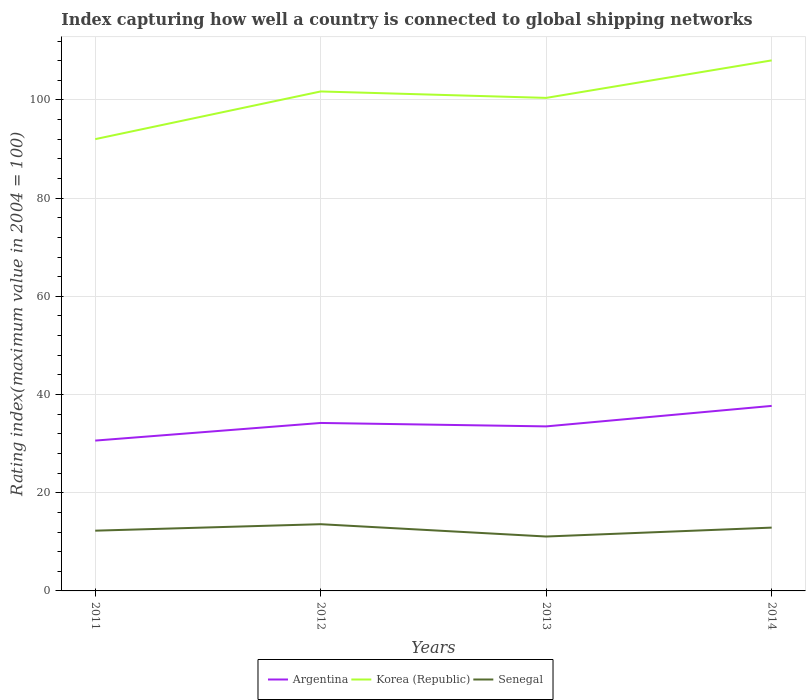How many different coloured lines are there?
Offer a very short reply. 3. Does the line corresponding to Argentina intersect with the line corresponding to Senegal?
Ensure brevity in your answer.  No. Across all years, what is the maximum rating index in Korea (Republic)?
Keep it short and to the point. 92.02. In which year was the rating index in Argentina maximum?
Your answer should be compact. 2011. What is the total rating index in Argentina in the graph?
Offer a terse response. -7.07. What is the difference between the highest and the second highest rating index in Senegal?
Keep it short and to the point. 2.51. How many lines are there?
Offer a terse response. 3. How many years are there in the graph?
Give a very brief answer. 4. What is the difference between two consecutive major ticks on the Y-axis?
Your answer should be very brief. 20. Does the graph contain any zero values?
Give a very brief answer. No. Does the graph contain grids?
Ensure brevity in your answer.  Yes. Where does the legend appear in the graph?
Provide a succinct answer. Bottom center. How many legend labels are there?
Make the answer very short. 3. What is the title of the graph?
Offer a very short reply. Index capturing how well a country is connected to global shipping networks. Does "Vietnam" appear as one of the legend labels in the graph?
Make the answer very short. No. What is the label or title of the X-axis?
Offer a very short reply. Years. What is the label or title of the Y-axis?
Offer a very short reply. Rating index(maximum value in 2004 = 100). What is the Rating index(maximum value in 2004 = 100) of Argentina in 2011?
Provide a short and direct response. 30.62. What is the Rating index(maximum value in 2004 = 100) of Korea (Republic) in 2011?
Offer a very short reply. 92.02. What is the Rating index(maximum value in 2004 = 100) in Senegal in 2011?
Provide a succinct answer. 12.27. What is the Rating index(maximum value in 2004 = 100) of Argentina in 2012?
Offer a very short reply. 34.21. What is the Rating index(maximum value in 2004 = 100) of Korea (Republic) in 2012?
Offer a terse response. 101.73. What is the Rating index(maximum value in 2004 = 100) in Senegal in 2012?
Provide a succinct answer. 13.59. What is the Rating index(maximum value in 2004 = 100) of Argentina in 2013?
Offer a terse response. 33.51. What is the Rating index(maximum value in 2004 = 100) in Korea (Republic) in 2013?
Your answer should be compact. 100.42. What is the Rating index(maximum value in 2004 = 100) in Senegal in 2013?
Ensure brevity in your answer.  11.08. What is the Rating index(maximum value in 2004 = 100) of Argentina in 2014?
Make the answer very short. 37.69. What is the Rating index(maximum value in 2004 = 100) of Korea (Republic) in 2014?
Keep it short and to the point. 108.06. What is the Rating index(maximum value in 2004 = 100) in Senegal in 2014?
Make the answer very short. 12.9. Across all years, what is the maximum Rating index(maximum value in 2004 = 100) of Argentina?
Your response must be concise. 37.69. Across all years, what is the maximum Rating index(maximum value in 2004 = 100) of Korea (Republic)?
Your answer should be compact. 108.06. Across all years, what is the maximum Rating index(maximum value in 2004 = 100) in Senegal?
Make the answer very short. 13.59. Across all years, what is the minimum Rating index(maximum value in 2004 = 100) of Argentina?
Give a very brief answer. 30.62. Across all years, what is the minimum Rating index(maximum value in 2004 = 100) in Korea (Republic)?
Your answer should be very brief. 92.02. Across all years, what is the minimum Rating index(maximum value in 2004 = 100) in Senegal?
Offer a terse response. 11.08. What is the total Rating index(maximum value in 2004 = 100) of Argentina in the graph?
Offer a terse response. 136.03. What is the total Rating index(maximum value in 2004 = 100) in Korea (Republic) in the graph?
Provide a succinct answer. 402.23. What is the total Rating index(maximum value in 2004 = 100) of Senegal in the graph?
Your answer should be very brief. 49.84. What is the difference between the Rating index(maximum value in 2004 = 100) in Argentina in 2011 and that in 2012?
Provide a succinct answer. -3.59. What is the difference between the Rating index(maximum value in 2004 = 100) of Korea (Republic) in 2011 and that in 2012?
Your answer should be very brief. -9.71. What is the difference between the Rating index(maximum value in 2004 = 100) of Senegal in 2011 and that in 2012?
Your answer should be compact. -1.32. What is the difference between the Rating index(maximum value in 2004 = 100) of Argentina in 2011 and that in 2013?
Provide a short and direct response. -2.89. What is the difference between the Rating index(maximum value in 2004 = 100) in Korea (Republic) in 2011 and that in 2013?
Keep it short and to the point. -8.4. What is the difference between the Rating index(maximum value in 2004 = 100) of Senegal in 2011 and that in 2013?
Provide a succinct answer. 1.19. What is the difference between the Rating index(maximum value in 2004 = 100) of Argentina in 2011 and that in 2014?
Provide a short and direct response. -7.07. What is the difference between the Rating index(maximum value in 2004 = 100) in Korea (Republic) in 2011 and that in 2014?
Your answer should be very brief. -16.04. What is the difference between the Rating index(maximum value in 2004 = 100) of Senegal in 2011 and that in 2014?
Offer a terse response. -0.63. What is the difference between the Rating index(maximum value in 2004 = 100) of Argentina in 2012 and that in 2013?
Ensure brevity in your answer.  0.7. What is the difference between the Rating index(maximum value in 2004 = 100) of Korea (Republic) in 2012 and that in 2013?
Your response must be concise. 1.31. What is the difference between the Rating index(maximum value in 2004 = 100) in Senegal in 2012 and that in 2013?
Make the answer very short. 2.51. What is the difference between the Rating index(maximum value in 2004 = 100) in Argentina in 2012 and that in 2014?
Offer a terse response. -3.48. What is the difference between the Rating index(maximum value in 2004 = 100) of Korea (Republic) in 2012 and that in 2014?
Make the answer very short. -6.33. What is the difference between the Rating index(maximum value in 2004 = 100) in Senegal in 2012 and that in 2014?
Make the answer very short. 0.69. What is the difference between the Rating index(maximum value in 2004 = 100) in Argentina in 2013 and that in 2014?
Your answer should be very brief. -4.18. What is the difference between the Rating index(maximum value in 2004 = 100) in Korea (Republic) in 2013 and that in 2014?
Your answer should be very brief. -7.64. What is the difference between the Rating index(maximum value in 2004 = 100) in Senegal in 2013 and that in 2014?
Give a very brief answer. -1.82. What is the difference between the Rating index(maximum value in 2004 = 100) in Argentina in 2011 and the Rating index(maximum value in 2004 = 100) in Korea (Republic) in 2012?
Provide a succinct answer. -71.11. What is the difference between the Rating index(maximum value in 2004 = 100) of Argentina in 2011 and the Rating index(maximum value in 2004 = 100) of Senegal in 2012?
Your answer should be compact. 17.03. What is the difference between the Rating index(maximum value in 2004 = 100) of Korea (Republic) in 2011 and the Rating index(maximum value in 2004 = 100) of Senegal in 2012?
Provide a short and direct response. 78.43. What is the difference between the Rating index(maximum value in 2004 = 100) of Argentina in 2011 and the Rating index(maximum value in 2004 = 100) of Korea (Republic) in 2013?
Ensure brevity in your answer.  -69.8. What is the difference between the Rating index(maximum value in 2004 = 100) of Argentina in 2011 and the Rating index(maximum value in 2004 = 100) of Senegal in 2013?
Ensure brevity in your answer.  19.54. What is the difference between the Rating index(maximum value in 2004 = 100) in Korea (Republic) in 2011 and the Rating index(maximum value in 2004 = 100) in Senegal in 2013?
Give a very brief answer. 80.94. What is the difference between the Rating index(maximum value in 2004 = 100) in Argentina in 2011 and the Rating index(maximum value in 2004 = 100) in Korea (Republic) in 2014?
Keep it short and to the point. -77.44. What is the difference between the Rating index(maximum value in 2004 = 100) of Argentina in 2011 and the Rating index(maximum value in 2004 = 100) of Senegal in 2014?
Offer a terse response. 17.72. What is the difference between the Rating index(maximum value in 2004 = 100) of Korea (Republic) in 2011 and the Rating index(maximum value in 2004 = 100) of Senegal in 2014?
Offer a very short reply. 79.12. What is the difference between the Rating index(maximum value in 2004 = 100) of Argentina in 2012 and the Rating index(maximum value in 2004 = 100) of Korea (Republic) in 2013?
Ensure brevity in your answer.  -66.21. What is the difference between the Rating index(maximum value in 2004 = 100) of Argentina in 2012 and the Rating index(maximum value in 2004 = 100) of Senegal in 2013?
Provide a short and direct response. 23.13. What is the difference between the Rating index(maximum value in 2004 = 100) in Korea (Republic) in 2012 and the Rating index(maximum value in 2004 = 100) in Senegal in 2013?
Offer a terse response. 90.65. What is the difference between the Rating index(maximum value in 2004 = 100) of Argentina in 2012 and the Rating index(maximum value in 2004 = 100) of Korea (Republic) in 2014?
Offer a very short reply. -73.85. What is the difference between the Rating index(maximum value in 2004 = 100) of Argentina in 2012 and the Rating index(maximum value in 2004 = 100) of Senegal in 2014?
Your answer should be compact. 21.31. What is the difference between the Rating index(maximum value in 2004 = 100) in Korea (Republic) in 2012 and the Rating index(maximum value in 2004 = 100) in Senegal in 2014?
Your response must be concise. 88.83. What is the difference between the Rating index(maximum value in 2004 = 100) in Argentina in 2013 and the Rating index(maximum value in 2004 = 100) in Korea (Republic) in 2014?
Give a very brief answer. -74.55. What is the difference between the Rating index(maximum value in 2004 = 100) of Argentina in 2013 and the Rating index(maximum value in 2004 = 100) of Senegal in 2014?
Your response must be concise. 20.61. What is the difference between the Rating index(maximum value in 2004 = 100) in Korea (Republic) in 2013 and the Rating index(maximum value in 2004 = 100) in Senegal in 2014?
Your answer should be very brief. 87.52. What is the average Rating index(maximum value in 2004 = 100) of Argentina per year?
Provide a short and direct response. 34.01. What is the average Rating index(maximum value in 2004 = 100) of Korea (Republic) per year?
Your answer should be very brief. 100.56. What is the average Rating index(maximum value in 2004 = 100) of Senegal per year?
Provide a short and direct response. 12.46. In the year 2011, what is the difference between the Rating index(maximum value in 2004 = 100) of Argentina and Rating index(maximum value in 2004 = 100) of Korea (Republic)?
Keep it short and to the point. -61.4. In the year 2011, what is the difference between the Rating index(maximum value in 2004 = 100) of Argentina and Rating index(maximum value in 2004 = 100) of Senegal?
Offer a very short reply. 18.35. In the year 2011, what is the difference between the Rating index(maximum value in 2004 = 100) of Korea (Republic) and Rating index(maximum value in 2004 = 100) of Senegal?
Provide a succinct answer. 79.75. In the year 2012, what is the difference between the Rating index(maximum value in 2004 = 100) of Argentina and Rating index(maximum value in 2004 = 100) of Korea (Republic)?
Your answer should be very brief. -67.52. In the year 2012, what is the difference between the Rating index(maximum value in 2004 = 100) of Argentina and Rating index(maximum value in 2004 = 100) of Senegal?
Give a very brief answer. 20.62. In the year 2012, what is the difference between the Rating index(maximum value in 2004 = 100) of Korea (Republic) and Rating index(maximum value in 2004 = 100) of Senegal?
Your response must be concise. 88.14. In the year 2013, what is the difference between the Rating index(maximum value in 2004 = 100) in Argentina and Rating index(maximum value in 2004 = 100) in Korea (Republic)?
Make the answer very short. -66.91. In the year 2013, what is the difference between the Rating index(maximum value in 2004 = 100) of Argentina and Rating index(maximum value in 2004 = 100) of Senegal?
Give a very brief answer. 22.43. In the year 2013, what is the difference between the Rating index(maximum value in 2004 = 100) in Korea (Republic) and Rating index(maximum value in 2004 = 100) in Senegal?
Offer a very short reply. 89.34. In the year 2014, what is the difference between the Rating index(maximum value in 2004 = 100) in Argentina and Rating index(maximum value in 2004 = 100) in Korea (Republic)?
Ensure brevity in your answer.  -70.37. In the year 2014, what is the difference between the Rating index(maximum value in 2004 = 100) of Argentina and Rating index(maximum value in 2004 = 100) of Senegal?
Your response must be concise. 24.79. In the year 2014, what is the difference between the Rating index(maximum value in 2004 = 100) in Korea (Republic) and Rating index(maximum value in 2004 = 100) in Senegal?
Your response must be concise. 95.16. What is the ratio of the Rating index(maximum value in 2004 = 100) in Argentina in 2011 to that in 2012?
Ensure brevity in your answer.  0.9. What is the ratio of the Rating index(maximum value in 2004 = 100) of Korea (Republic) in 2011 to that in 2012?
Provide a short and direct response. 0.9. What is the ratio of the Rating index(maximum value in 2004 = 100) of Senegal in 2011 to that in 2012?
Provide a succinct answer. 0.9. What is the ratio of the Rating index(maximum value in 2004 = 100) of Argentina in 2011 to that in 2013?
Offer a terse response. 0.91. What is the ratio of the Rating index(maximum value in 2004 = 100) in Korea (Republic) in 2011 to that in 2013?
Keep it short and to the point. 0.92. What is the ratio of the Rating index(maximum value in 2004 = 100) of Senegal in 2011 to that in 2013?
Give a very brief answer. 1.11. What is the ratio of the Rating index(maximum value in 2004 = 100) of Argentina in 2011 to that in 2014?
Ensure brevity in your answer.  0.81. What is the ratio of the Rating index(maximum value in 2004 = 100) of Korea (Republic) in 2011 to that in 2014?
Provide a succinct answer. 0.85. What is the ratio of the Rating index(maximum value in 2004 = 100) of Senegal in 2011 to that in 2014?
Provide a short and direct response. 0.95. What is the ratio of the Rating index(maximum value in 2004 = 100) of Argentina in 2012 to that in 2013?
Offer a very short reply. 1.02. What is the ratio of the Rating index(maximum value in 2004 = 100) of Korea (Republic) in 2012 to that in 2013?
Make the answer very short. 1.01. What is the ratio of the Rating index(maximum value in 2004 = 100) of Senegal in 2012 to that in 2013?
Make the answer very short. 1.23. What is the ratio of the Rating index(maximum value in 2004 = 100) in Argentina in 2012 to that in 2014?
Ensure brevity in your answer.  0.91. What is the ratio of the Rating index(maximum value in 2004 = 100) of Korea (Republic) in 2012 to that in 2014?
Offer a terse response. 0.94. What is the ratio of the Rating index(maximum value in 2004 = 100) in Senegal in 2012 to that in 2014?
Keep it short and to the point. 1.05. What is the ratio of the Rating index(maximum value in 2004 = 100) of Argentina in 2013 to that in 2014?
Ensure brevity in your answer.  0.89. What is the ratio of the Rating index(maximum value in 2004 = 100) of Korea (Republic) in 2013 to that in 2014?
Give a very brief answer. 0.93. What is the ratio of the Rating index(maximum value in 2004 = 100) in Senegal in 2013 to that in 2014?
Make the answer very short. 0.86. What is the difference between the highest and the second highest Rating index(maximum value in 2004 = 100) in Argentina?
Your answer should be very brief. 3.48. What is the difference between the highest and the second highest Rating index(maximum value in 2004 = 100) in Korea (Republic)?
Keep it short and to the point. 6.33. What is the difference between the highest and the second highest Rating index(maximum value in 2004 = 100) in Senegal?
Keep it short and to the point. 0.69. What is the difference between the highest and the lowest Rating index(maximum value in 2004 = 100) in Argentina?
Keep it short and to the point. 7.07. What is the difference between the highest and the lowest Rating index(maximum value in 2004 = 100) in Korea (Republic)?
Offer a terse response. 16.04. What is the difference between the highest and the lowest Rating index(maximum value in 2004 = 100) of Senegal?
Your answer should be very brief. 2.51. 